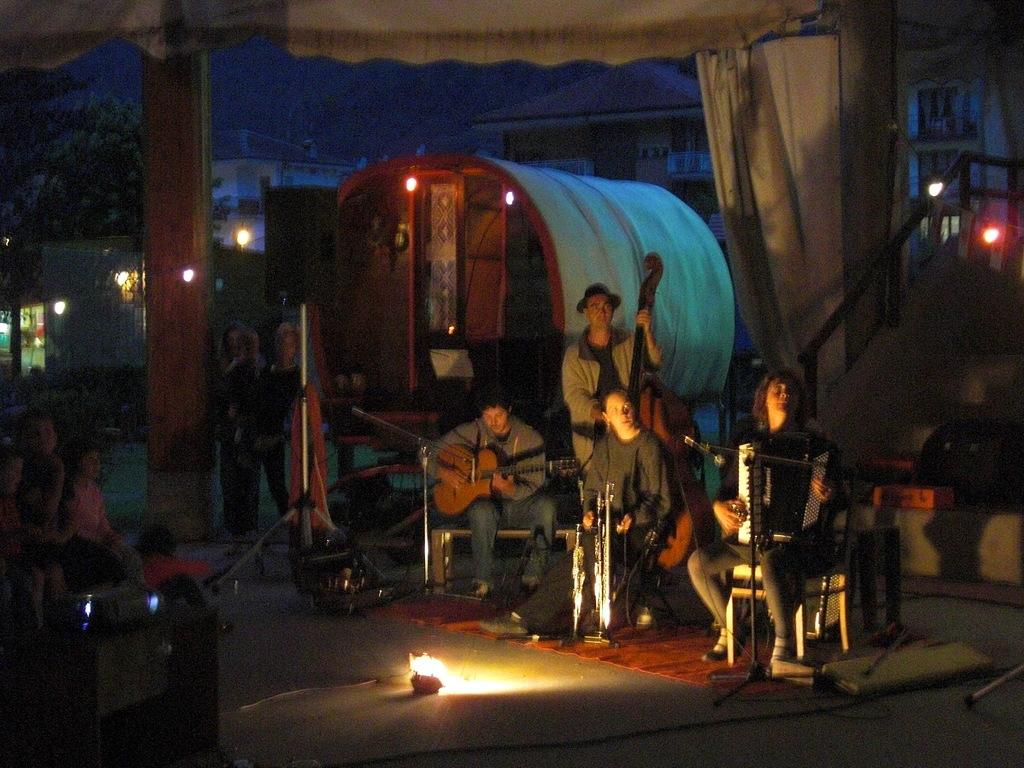How many people are in the image? There are people in the image, but the exact number is not specified. What are the people in the image doing? Some people are sitting, and some people are standing. What else can be seen in the image besides people? There are musical instruments, lights, and other objects on the ground in the image. How much wealth does the ghost in the image possess? There is no ghost present in the image, so it is not possible to determine the wealth of a ghost. 